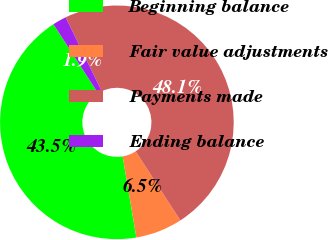<chart> <loc_0><loc_0><loc_500><loc_500><pie_chart><fcel>Beginning balance<fcel>Fair value adjustments<fcel>Payments made<fcel>Ending balance<nl><fcel>43.53%<fcel>6.47%<fcel>48.09%<fcel>1.91%<nl></chart> 